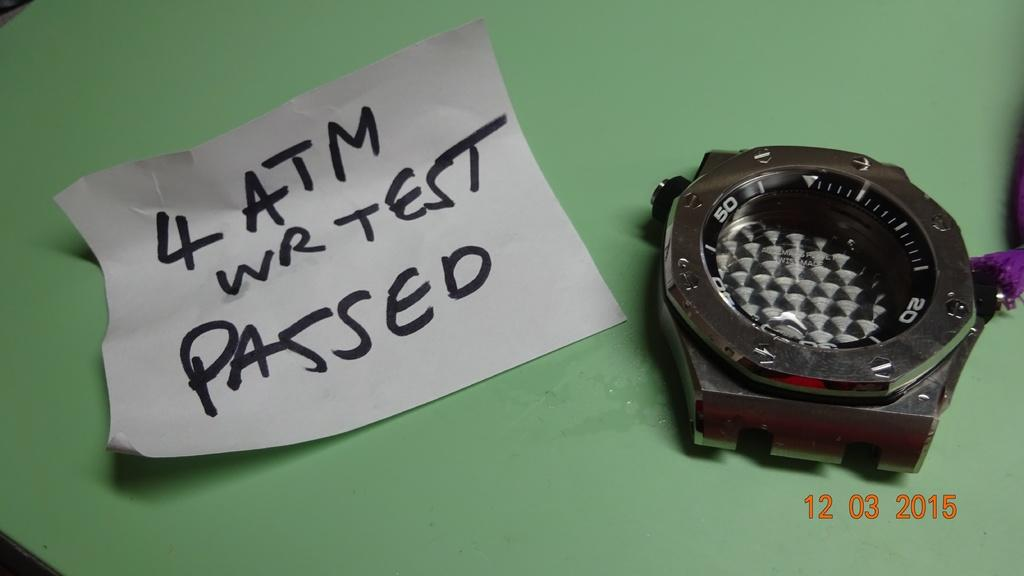<image>
Describe the image concisely. "4 ATM WR TEST PASSED" is on a piece of paper by a watch. 